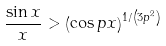<formula> <loc_0><loc_0><loc_500><loc_500>\frac { \sin x } { x } > \left ( \cos p x \right ) ^ { 1 / \left ( 3 p ^ { 2 } \right ) }</formula> 